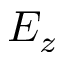<formula> <loc_0><loc_0><loc_500><loc_500>E _ { z }</formula> 